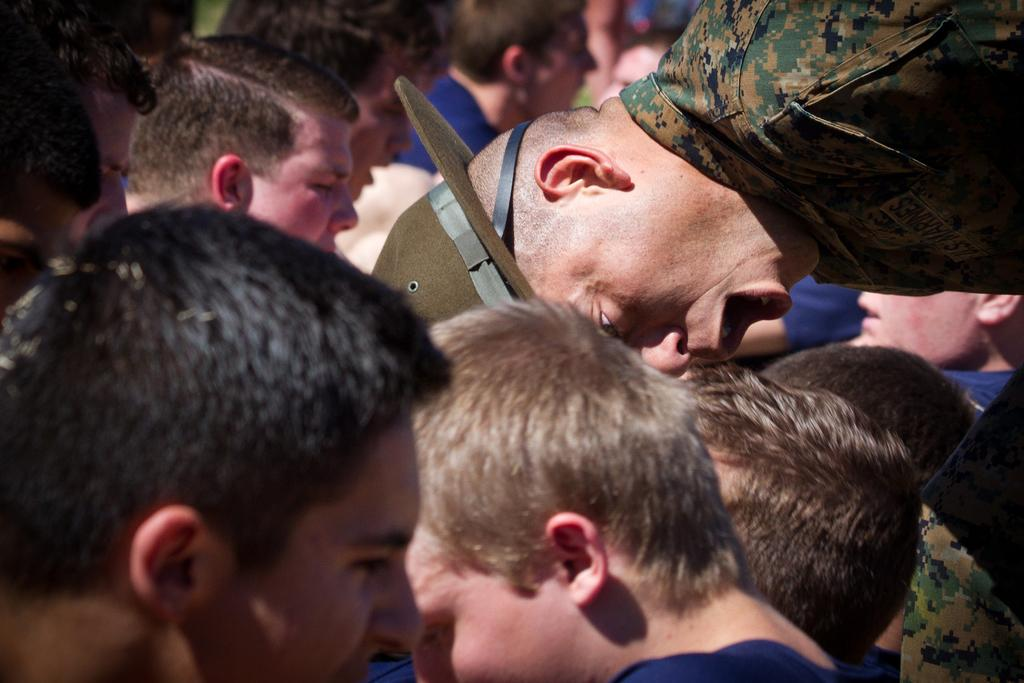What is the main subject of the image? The main subject of the image is a group of people. Can you describe any specific items or accessories in the image? Yes, there is a hat visible in the image. What can be observed about the background of the image? The background of the image is blurry. How many quince are being held by the boys in the image? There are no boys or quince present in the image. What type of skin condition can be seen on the people in the image? There is no indication of any skin condition on the people in the image. 